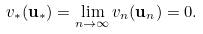<formula> <loc_0><loc_0><loc_500><loc_500>v _ { * } ( \mathbf u _ { * } ) = \lim _ { n \to \infty } v _ { n } ( \mathbf u _ { n } ) = 0 .</formula> 